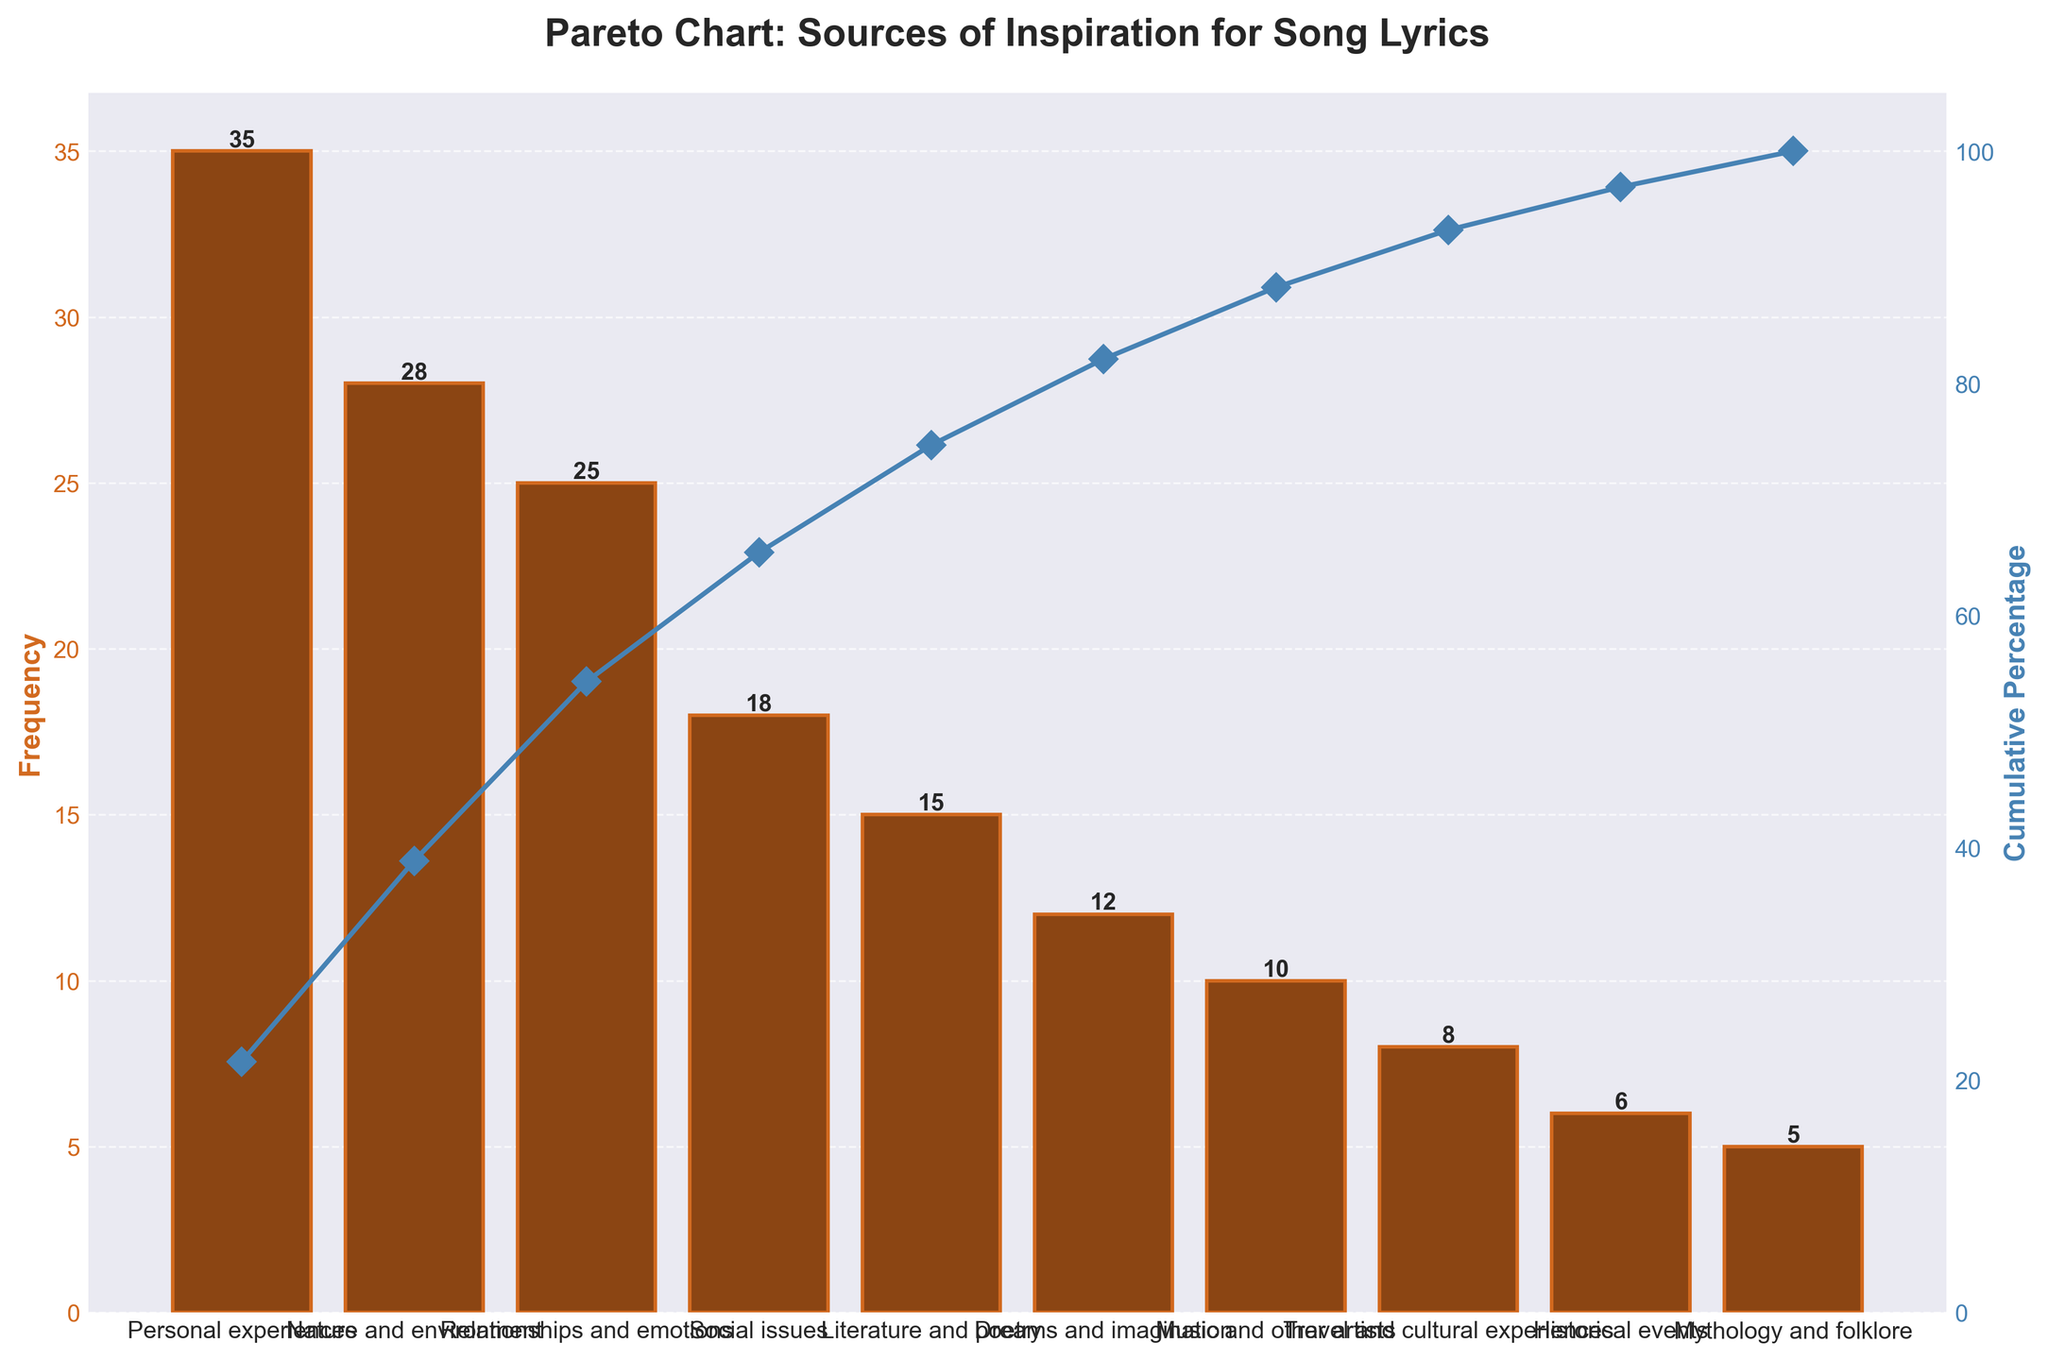what is the most frequent source of inspiration for song lyrics? The figure shows a bar chart where the height of each bar represents the frequency of each inspiration source. The tallest bar indicates the most frequent source.
Answer: Personal experiences what is the title of the chart? The title is usually located at the top of the chart and summarizes what the chart is about.
Answer: Pareto Chart: Sources of Inspiration for Song Lyrics how many inspiration sources have a frequency greater than 20? By looking at the heights or values of the bars, we can count how many sources exceed the frequency of 20.
Answer: Three what is the cumulative percentage for "Social issues"? The cumulative percentage line for "Social issues" should be observed and the exact value can be read from the secondary y-axis.
Answer: 55% which source of inspiration has the least frequency? The shortest bar on the chart represents the least frequent source.
Answer: Mythology and folklore how much more frequent is "Nature and environment" compared to "Dreams and imagination"? The frequency of "Nature and environment" minus the frequency of "Dreams and imagination".
Answer: 16 what are the frequencies of the top three sources of inspiration combined? Add the frequencies of the top three sources: Personal experiences (35), Nature and environment (28), and Relationships and emotions (25).
Answer: 88 which three sources combined reach close to a 50% cumulative percentage? By checking the cumulative percentage line, identify the categories that reach close to 50%: Personal experiences (35), Nature and environment (28), and Relationships and emotions (25).
Answer: Personal experiences, Nature and environment, Relationships and emotions are there any sources of inspiration that contribute equally (10) to the frequency? Count if there is any bar with the same height which corresponds to the frequency of 10.
Answer: Yes, Music and other artists between "Literature and poetry" and "Travel and cultural experiences", which one has a higher frequency? Compare the heights or values of the corresponding bars.
Answer: Literature and poetry 